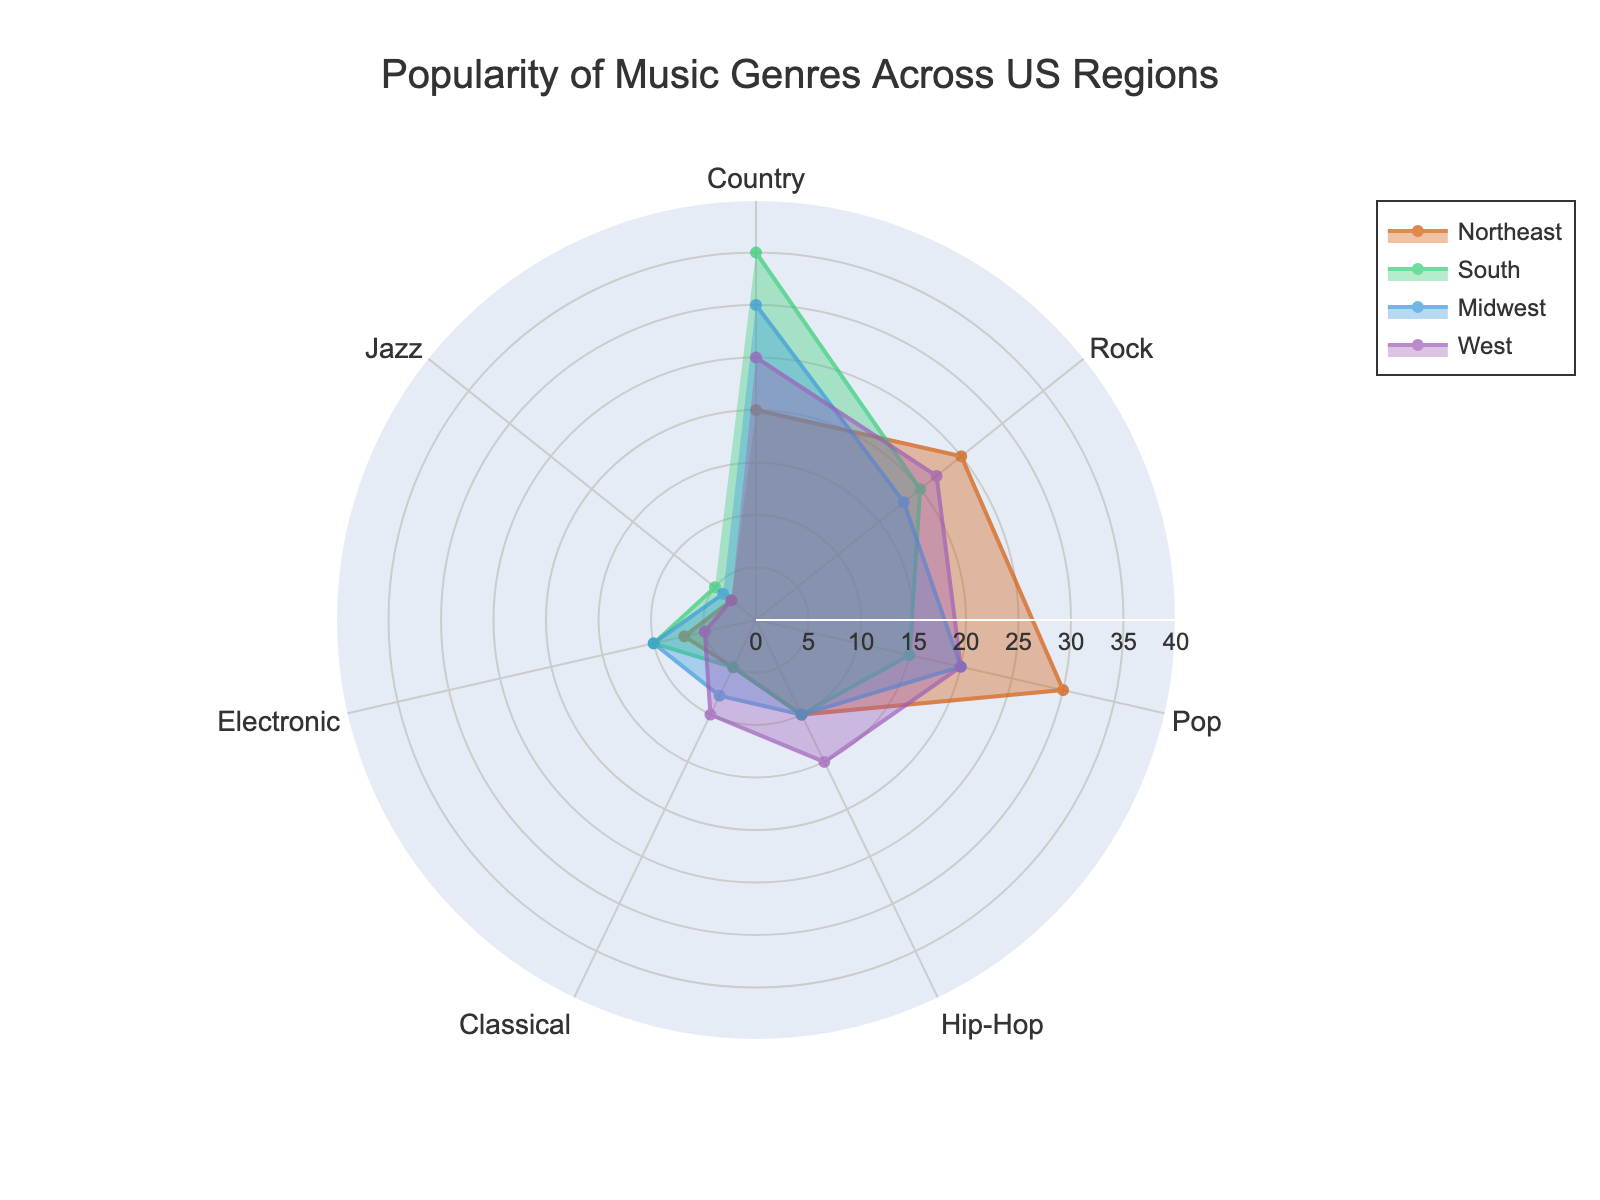What's the title of the figure? The title is located at the top of the figure and is a clear indication of what the radar chart represents.
Answer: Popularity of Music Genres Across US Regions How many regions are compared in the radar chart? By counting the different regions listed in the legend or the plot traces, we can determine the number of regions.
Answer: 4 Which region has the highest popularity for the Country genre? By looking at the plot and comparing the values for the Country genre across all regions, the region with the highest value can be identified. The South region reaches the largest radial extend for Country genre.
Answer: South What is the range of the radial axis? The radial axis range is shown by the numbers along the radial lines.
Answer: 0 to 40 Which music genre is least popular in the West region? By examining the plot lines for the West region across all genres, the genre with the lowest value can be identified.
Answer: Jazz What is the average popularity of Rock genre across all regions? Sum the Rock values for all regions and then divide by the number of regions: (25 + 20 + 18 + 22) / 4.
Answer: 21.25 Compare the popularity of Classical and Electronic genres in the Northeast region. Which one is more popular? By looking at the values of Classical and Electronic genres for the Northeast region, we can compare their heights. Classical is at 10 while Electronic is at 7.
Answer: Classical Which genre is more evenly liked across all regions, Jazz or Hip-Hop? By comparing the plot lines for Jazz and Hip-Hop across all regions, we can see which genre has less variation in popularity across regions.
Answer: Jazz Does any region have an equal popularity value for two different genres? Check each region's plot lines across all genres to see if any values match exactly.
Answer: No 